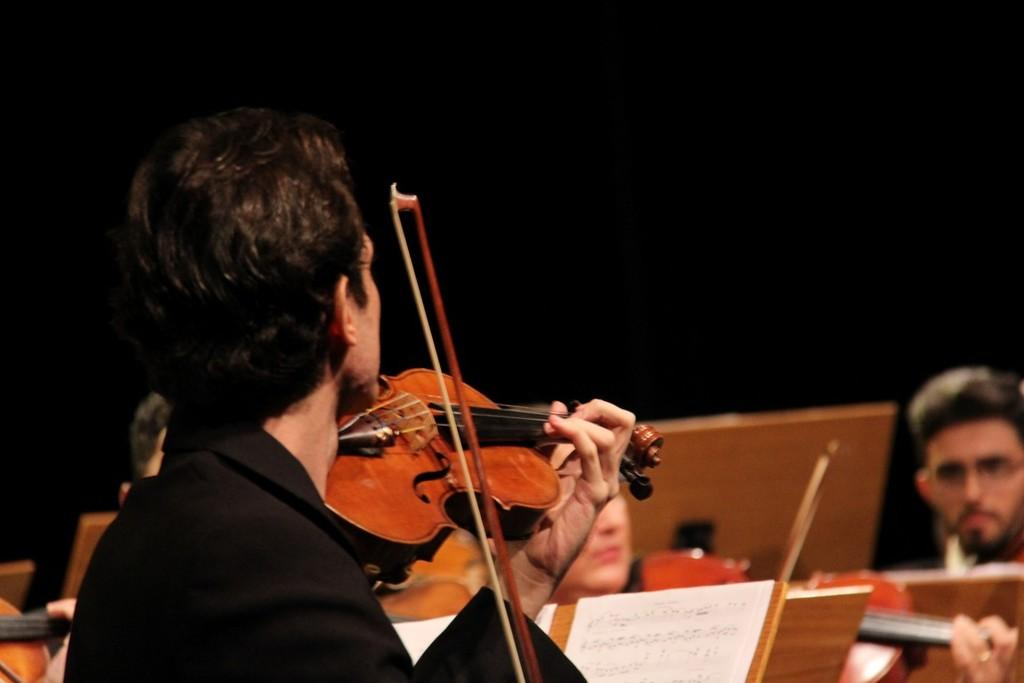What is the man in the image doing? The man is standing in the image and holding a music instrument. Can you describe the music instrument the man is holding? The music instrument is yellow in color. What can be seen in the background of the image? There are people sitting in the background of the image. Does the man in the image have any regrets about his pet rabbit? There is no information about a pet rabbit or any regrets in the image, so we cannot answer this question. 